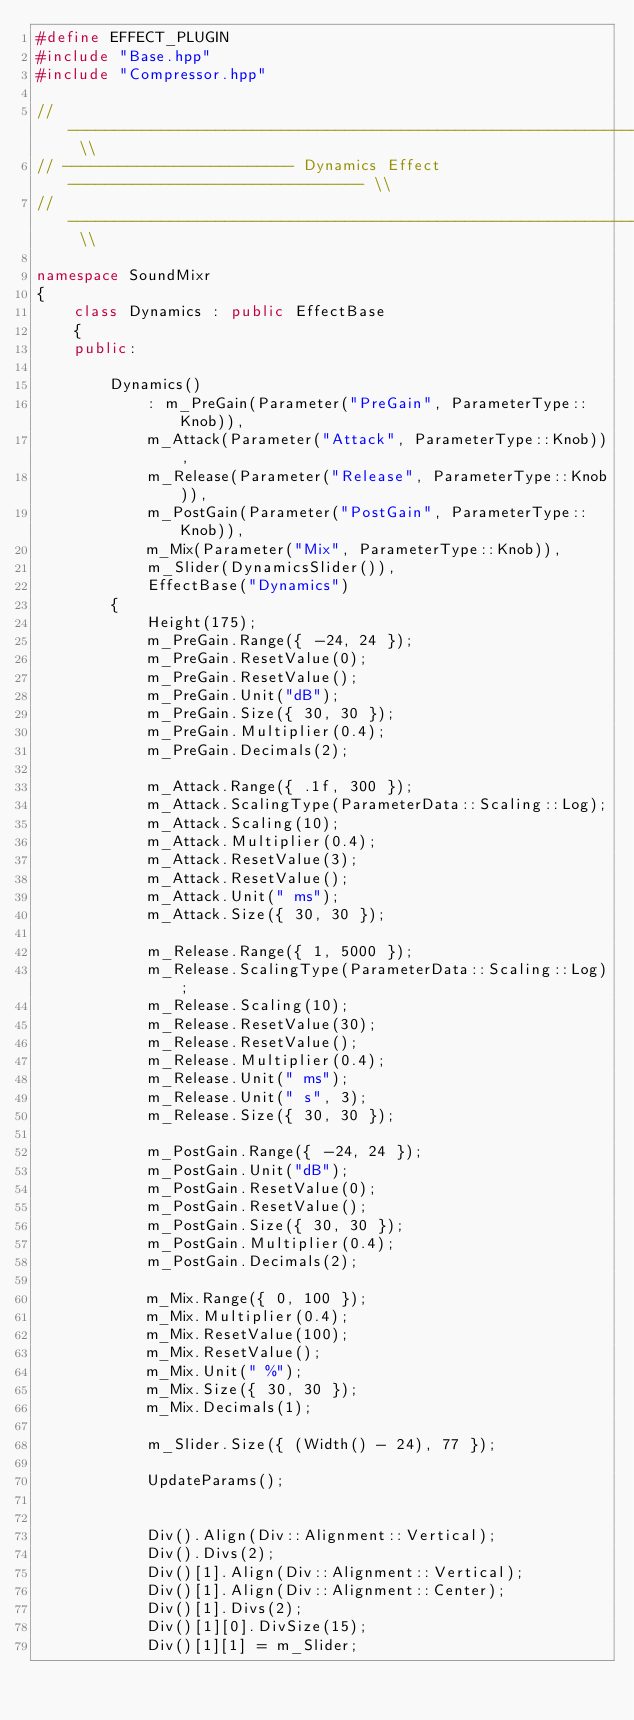Convert code to text. <code><loc_0><loc_0><loc_500><loc_500><_C++_>#define EFFECT_PLUGIN
#include "Base.hpp"
#include "Compressor.hpp"

// -------------------------------------------------------------------------- \\
// ------------------------- Dynamics Effect -------------------------------- \\
// -------------------------------------------------------------------------- \\

namespace SoundMixr
{
	class Dynamics : public EffectBase
	{
	public:

		Dynamics()
			: m_PreGain(Parameter("PreGain", ParameterType::Knob)),
			m_Attack(Parameter("Attack", ParameterType::Knob)),
			m_Release(Parameter("Release", ParameterType::Knob)),
			m_PostGain(Parameter("PostGain", ParameterType::Knob)),
			m_Mix(Parameter("Mix", ParameterType::Knob)),
			m_Slider(DynamicsSlider()),
			EffectBase("Dynamics")
		{
			Height(175);
			m_PreGain.Range({ -24, 24 });
			m_PreGain.ResetValue(0);
			m_PreGain.ResetValue();
			m_PreGain.Unit("dB");
			m_PreGain.Size({ 30, 30 });
			m_PreGain.Multiplier(0.4);
			m_PreGain.Decimals(2);

			m_Attack.Range({ .1f, 300 });
			m_Attack.ScalingType(ParameterData::Scaling::Log);
			m_Attack.Scaling(10);
			m_Attack.Multiplier(0.4);
			m_Attack.ResetValue(3);
			m_Attack.ResetValue();
			m_Attack.Unit(" ms");
			m_Attack.Size({ 30, 30 });

			m_Release.Range({ 1, 5000 });
			m_Release.ScalingType(ParameterData::Scaling::Log);
			m_Release.Scaling(10);
			m_Release.ResetValue(30);
			m_Release.ResetValue();
			m_Release.Multiplier(0.4);
			m_Release.Unit(" ms");
			m_Release.Unit(" s", 3);
			m_Release.Size({ 30, 30 });

			m_PostGain.Range({ -24, 24 });
			m_PostGain.Unit("dB");
			m_PostGain.ResetValue(0);
			m_PostGain.ResetValue();
			m_PostGain.Size({ 30, 30 });
			m_PostGain.Multiplier(0.4);
			m_PostGain.Decimals(2);

			m_Mix.Range({ 0, 100 });
			m_Mix.Multiplier(0.4);
			m_Mix.ResetValue(100);
			m_Mix.ResetValue();
			m_Mix.Unit(" %");
			m_Mix.Size({ 30, 30 });
			m_Mix.Decimals(1);

			m_Slider.Size({ (Width() - 24), 77 });

			UpdateParams();


			Div().Align(Div::Alignment::Vertical);
			Div().Divs(2);
			Div()[1].Align(Div::Alignment::Vertical);
			Div()[1].Align(Div::Alignment::Center);
			Div()[1].Divs(2);
			Div()[1][0].DivSize(15);
			Div()[1][1] = m_Slider;</code> 